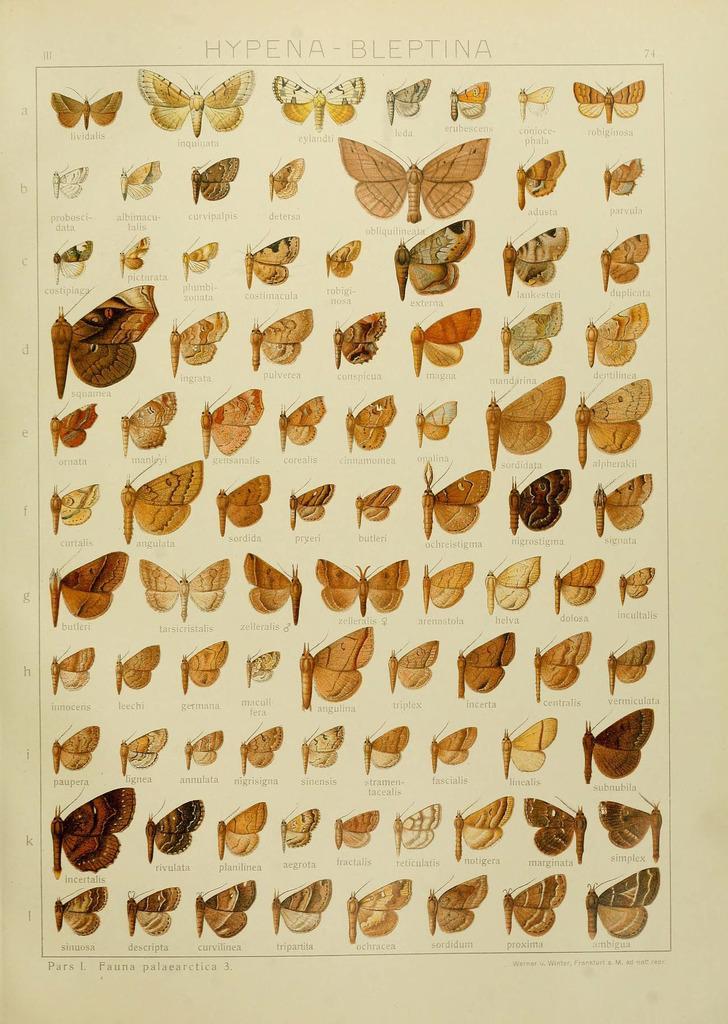Please provide a concise description of this image. This is a paper and here we can see butterflies and some text. 